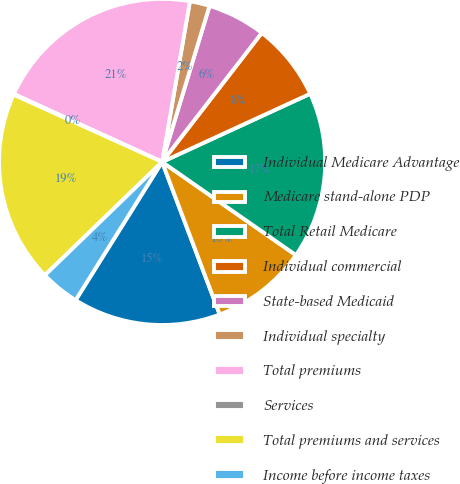Convert chart. <chart><loc_0><loc_0><loc_500><loc_500><pie_chart><fcel>Individual Medicare Advantage<fcel>Medicare stand-alone PDP<fcel>Total Retail Medicare<fcel>Individual commercial<fcel>State-based Medicaid<fcel>Individual specialty<fcel>Total premiums<fcel>Services<fcel>Total premiums and services<fcel>Income before income taxes<nl><fcel>14.65%<fcel>9.57%<fcel>16.55%<fcel>7.67%<fcel>5.77%<fcel>1.97%<fcel>20.89%<fcel>0.07%<fcel>19.0%<fcel>3.87%<nl></chart> 